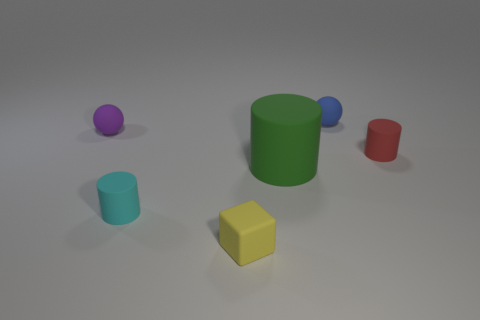Add 3 big red metal blocks. How many objects exist? 9 Subtract all blocks. How many objects are left? 5 Add 1 small red cylinders. How many small red cylinders are left? 2 Add 5 big green matte things. How many big green matte things exist? 6 Subtract 0 green blocks. How many objects are left? 6 Subtract all big gray metallic cubes. Subtract all small blue matte spheres. How many objects are left? 5 